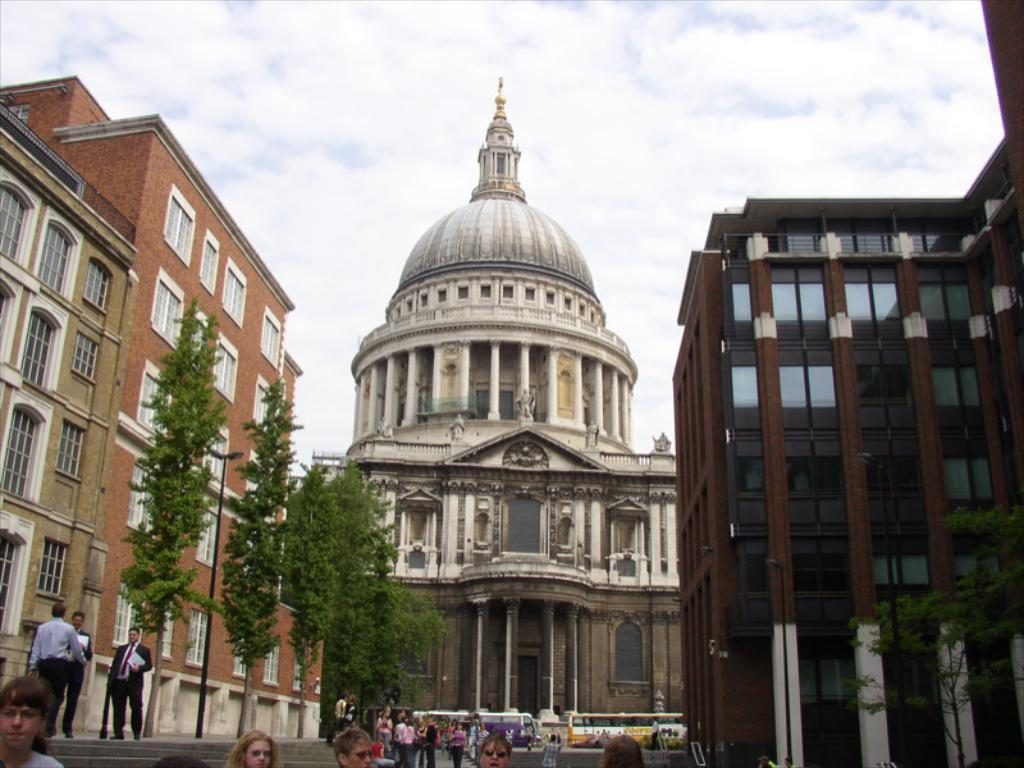What are the people at the bottom of the image doing? The people at the bottom of the image are standing and walking. What can be seen behind the people? There are trees and vehicles behind the people. What is located at the top of the image? There are buildings and clouds at the top of the image. What is visible in the sky at the top of the image? The sky is visible at the top of the image. Can you describe the seashore in the image? There is no seashore present in the image. What type of zephyr can be seen blowing through the bedroom in the image? There is no bedroom or zephyr present in the image. 